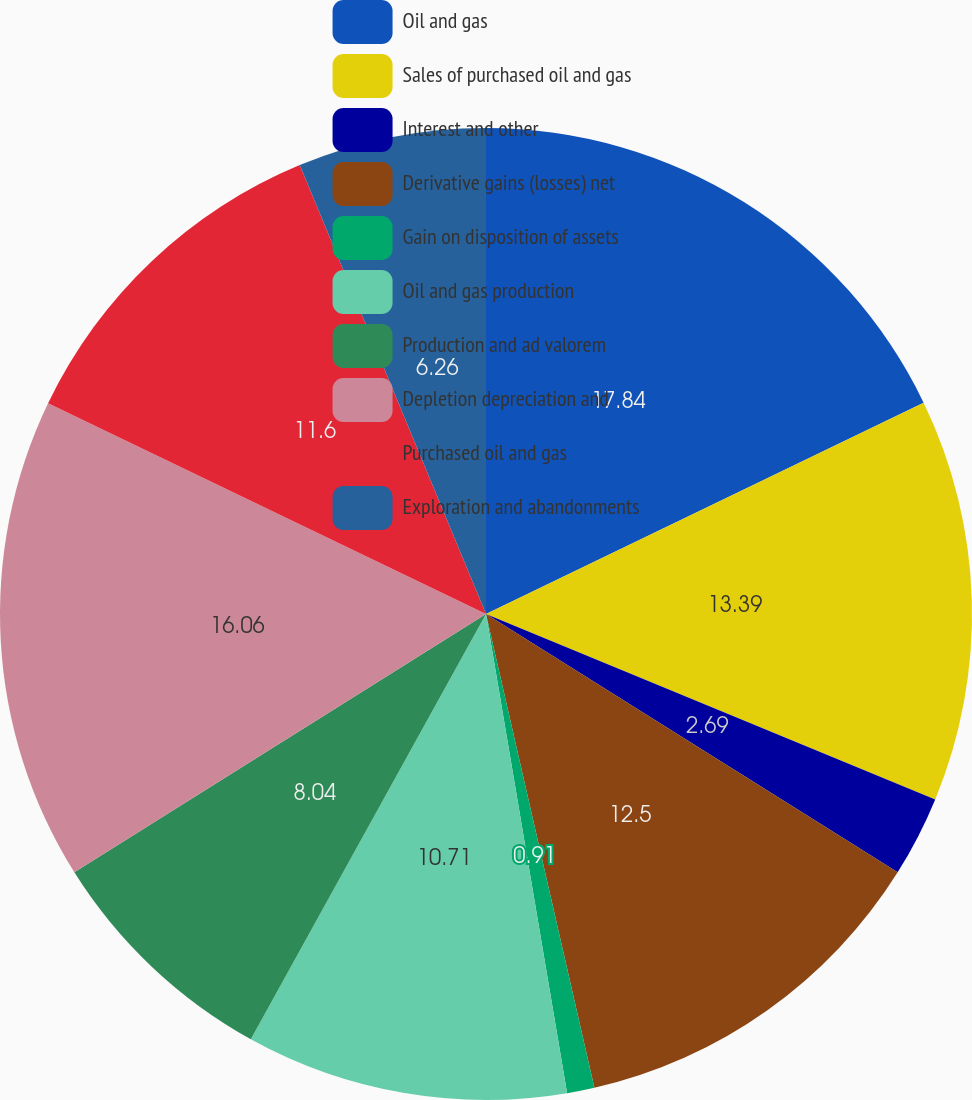Convert chart. <chart><loc_0><loc_0><loc_500><loc_500><pie_chart><fcel>Oil and gas<fcel>Sales of purchased oil and gas<fcel>Interest and other<fcel>Derivative gains (losses) net<fcel>Gain on disposition of assets<fcel>Oil and gas production<fcel>Production and ad valorem<fcel>Depletion depreciation and<fcel>Purchased oil and gas<fcel>Exploration and abandonments<nl><fcel>17.84%<fcel>13.39%<fcel>2.69%<fcel>12.5%<fcel>0.91%<fcel>10.71%<fcel>8.04%<fcel>16.06%<fcel>11.6%<fcel>6.26%<nl></chart> 